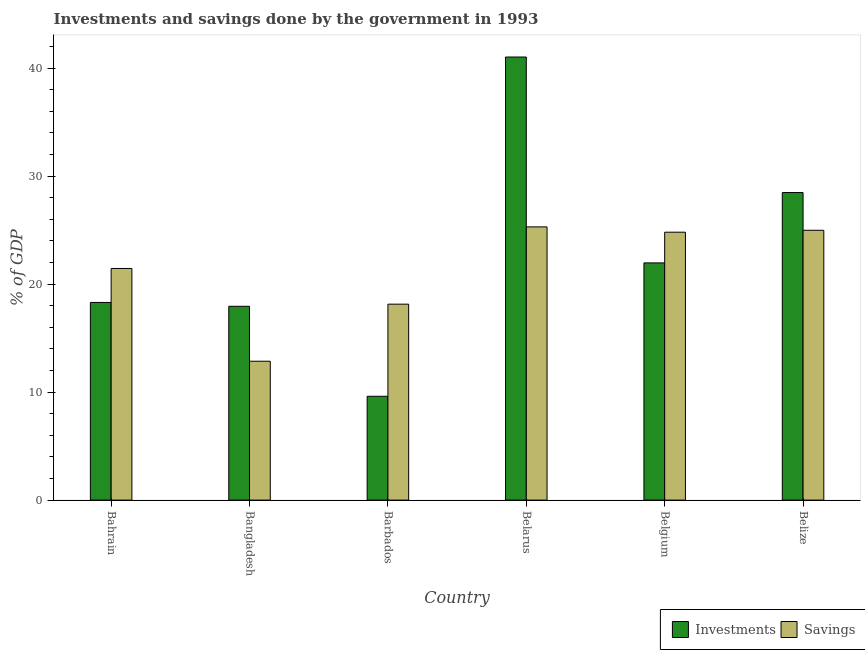How many different coloured bars are there?
Provide a short and direct response. 2. How many groups of bars are there?
Keep it short and to the point. 6. Are the number of bars per tick equal to the number of legend labels?
Offer a very short reply. Yes. How many bars are there on the 5th tick from the right?
Ensure brevity in your answer.  2. What is the label of the 4th group of bars from the left?
Give a very brief answer. Belarus. In how many cases, is the number of bars for a given country not equal to the number of legend labels?
Provide a short and direct response. 0. What is the savings of government in Belarus?
Your answer should be very brief. 25.3. Across all countries, what is the maximum savings of government?
Give a very brief answer. 25.3. Across all countries, what is the minimum savings of government?
Make the answer very short. 12.86. In which country was the investments of government maximum?
Provide a short and direct response. Belarus. In which country was the investments of government minimum?
Your answer should be very brief. Barbados. What is the total savings of government in the graph?
Provide a short and direct response. 127.55. What is the difference between the savings of government in Belarus and that in Belgium?
Provide a short and direct response. 0.49. What is the difference between the savings of government in Belize and the investments of government in Belgium?
Offer a terse response. 3.02. What is the average savings of government per country?
Your response must be concise. 21.26. What is the difference between the savings of government and investments of government in Belarus?
Your answer should be very brief. -15.73. What is the ratio of the investments of government in Bangladesh to that in Belarus?
Give a very brief answer. 0.44. Is the savings of government in Bahrain less than that in Belize?
Offer a terse response. Yes. Is the difference between the investments of government in Bahrain and Bangladesh greater than the difference between the savings of government in Bahrain and Bangladesh?
Provide a succinct answer. No. What is the difference between the highest and the second highest savings of government?
Your answer should be very brief. 0.31. What is the difference between the highest and the lowest investments of government?
Provide a short and direct response. 31.42. In how many countries, is the investments of government greater than the average investments of government taken over all countries?
Give a very brief answer. 2. Is the sum of the savings of government in Bahrain and Bangladesh greater than the maximum investments of government across all countries?
Offer a terse response. No. What does the 1st bar from the left in Bahrain represents?
Your answer should be very brief. Investments. What does the 1st bar from the right in Bahrain represents?
Your answer should be compact. Savings. How many bars are there?
Offer a very short reply. 12. How many countries are there in the graph?
Provide a short and direct response. 6. Are the values on the major ticks of Y-axis written in scientific E-notation?
Your response must be concise. No. Does the graph contain grids?
Your answer should be compact. No. How many legend labels are there?
Your answer should be very brief. 2. What is the title of the graph?
Keep it short and to the point. Investments and savings done by the government in 1993. What is the label or title of the X-axis?
Ensure brevity in your answer.  Country. What is the label or title of the Y-axis?
Give a very brief answer. % of GDP. What is the % of GDP in Investments in Bahrain?
Provide a short and direct response. 18.3. What is the % of GDP in Savings in Bahrain?
Your answer should be very brief. 21.45. What is the % of GDP in Investments in Bangladesh?
Your answer should be compact. 17.95. What is the % of GDP of Savings in Bangladesh?
Make the answer very short. 12.86. What is the % of GDP in Investments in Barbados?
Your answer should be compact. 9.61. What is the % of GDP in Savings in Barbados?
Ensure brevity in your answer.  18.14. What is the % of GDP of Investments in Belarus?
Offer a terse response. 41.03. What is the % of GDP of Savings in Belarus?
Your response must be concise. 25.3. What is the % of GDP in Investments in Belgium?
Keep it short and to the point. 21.97. What is the % of GDP in Savings in Belgium?
Your answer should be compact. 24.81. What is the % of GDP in Investments in Belize?
Ensure brevity in your answer.  28.48. What is the % of GDP of Savings in Belize?
Provide a succinct answer. 24.99. Across all countries, what is the maximum % of GDP in Investments?
Ensure brevity in your answer.  41.03. Across all countries, what is the maximum % of GDP in Savings?
Provide a succinct answer. 25.3. Across all countries, what is the minimum % of GDP of Investments?
Your answer should be compact. 9.61. Across all countries, what is the minimum % of GDP of Savings?
Give a very brief answer. 12.86. What is the total % of GDP in Investments in the graph?
Your answer should be compact. 137.34. What is the total % of GDP in Savings in the graph?
Provide a short and direct response. 127.55. What is the difference between the % of GDP in Investments in Bahrain and that in Bangladesh?
Provide a succinct answer. 0.36. What is the difference between the % of GDP of Savings in Bahrain and that in Bangladesh?
Make the answer very short. 8.59. What is the difference between the % of GDP in Investments in Bahrain and that in Barbados?
Give a very brief answer. 8.69. What is the difference between the % of GDP of Savings in Bahrain and that in Barbados?
Your answer should be compact. 3.3. What is the difference between the % of GDP of Investments in Bahrain and that in Belarus?
Keep it short and to the point. -22.73. What is the difference between the % of GDP in Savings in Bahrain and that in Belarus?
Your response must be concise. -3.85. What is the difference between the % of GDP of Investments in Bahrain and that in Belgium?
Ensure brevity in your answer.  -3.66. What is the difference between the % of GDP in Savings in Bahrain and that in Belgium?
Your response must be concise. -3.36. What is the difference between the % of GDP of Investments in Bahrain and that in Belize?
Make the answer very short. -10.18. What is the difference between the % of GDP of Savings in Bahrain and that in Belize?
Ensure brevity in your answer.  -3.54. What is the difference between the % of GDP of Investments in Bangladesh and that in Barbados?
Provide a succinct answer. 8.33. What is the difference between the % of GDP of Savings in Bangladesh and that in Barbados?
Ensure brevity in your answer.  -5.28. What is the difference between the % of GDP in Investments in Bangladesh and that in Belarus?
Provide a short and direct response. -23.08. What is the difference between the % of GDP of Savings in Bangladesh and that in Belarus?
Provide a short and direct response. -12.44. What is the difference between the % of GDP of Investments in Bangladesh and that in Belgium?
Offer a very short reply. -4.02. What is the difference between the % of GDP of Savings in Bangladesh and that in Belgium?
Offer a very short reply. -11.95. What is the difference between the % of GDP of Investments in Bangladesh and that in Belize?
Offer a terse response. -10.53. What is the difference between the % of GDP in Savings in Bangladesh and that in Belize?
Offer a terse response. -12.13. What is the difference between the % of GDP of Investments in Barbados and that in Belarus?
Provide a succinct answer. -31.42. What is the difference between the % of GDP of Savings in Barbados and that in Belarus?
Keep it short and to the point. -7.16. What is the difference between the % of GDP of Investments in Barbados and that in Belgium?
Keep it short and to the point. -12.35. What is the difference between the % of GDP in Savings in Barbados and that in Belgium?
Your answer should be compact. -6.67. What is the difference between the % of GDP in Investments in Barbados and that in Belize?
Your answer should be very brief. -18.87. What is the difference between the % of GDP of Savings in Barbados and that in Belize?
Provide a short and direct response. -6.84. What is the difference between the % of GDP of Investments in Belarus and that in Belgium?
Your answer should be compact. 19.06. What is the difference between the % of GDP of Savings in Belarus and that in Belgium?
Keep it short and to the point. 0.49. What is the difference between the % of GDP in Investments in Belarus and that in Belize?
Ensure brevity in your answer.  12.55. What is the difference between the % of GDP in Savings in Belarus and that in Belize?
Your answer should be very brief. 0.31. What is the difference between the % of GDP of Investments in Belgium and that in Belize?
Offer a terse response. -6.51. What is the difference between the % of GDP in Savings in Belgium and that in Belize?
Make the answer very short. -0.18. What is the difference between the % of GDP of Investments in Bahrain and the % of GDP of Savings in Bangladesh?
Provide a short and direct response. 5.44. What is the difference between the % of GDP of Investments in Bahrain and the % of GDP of Savings in Barbados?
Your answer should be compact. 0.16. What is the difference between the % of GDP of Investments in Bahrain and the % of GDP of Savings in Belarus?
Your answer should be very brief. -7. What is the difference between the % of GDP in Investments in Bahrain and the % of GDP in Savings in Belgium?
Ensure brevity in your answer.  -6.51. What is the difference between the % of GDP of Investments in Bahrain and the % of GDP of Savings in Belize?
Provide a succinct answer. -6.68. What is the difference between the % of GDP of Investments in Bangladesh and the % of GDP of Savings in Barbados?
Your answer should be very brief. -0.2. What is the difference between the % of GDP of Investments in Bangladesh and the % of GDP of Savings in Belarus?
Give a very brief answer. -7.35. What is the difference between the % of GDP in Investments in Bangladesh and the % of GDP in Savings in Belgium?
Your answer should be compact. -6.86. What is the difference between the % of GDP of Investments in Bangladesh and the % of GDP of Savings in Belize?
Your answer should be very brief. -7.04. What is the difference between the % of GDP of Investments in Barbados and the % of GDP of Savings in Belarus?
Provide a succinct answer. -15.69. What is the difference between the % of GDP of Investments in Barbados and the % of GDP of Savings in Belgium?
Your answer should be compact. -15.2. What is the difference between the % of GDP in Investments in Barbados and the % of GDP in Savings in Belize?
Offer a terse response. -15.37. What is the difference between the % of GDP in Investments in Belarus and the % of GDP in Savings in Belgium?
Provide a succinct answer. 16.22. What is the difference between the % of GDP of Investments in Belarus and the % of GDP of Savings in Belize?
Your response must be concise. 16.04. What is the difference between the % of GDP in Investments in Belgium and the % of GDP in Savings in Belize?
Ensure brevity in your answer.  -3.02. What is the average % of GDP in Investments per country?
Keep it short and to the point. 22.89. What is the average % of GDP of Savings per country?
Your answer should be very brief. 21.26. What is the difference between the % of GDP in Investments and % of GDP in Savings in Bahrain?
Your response must be concise. -3.15. What is the difference between the % of GDP in Investments and % of GDP in Savings in Bangladesh?
Offer a terse response. 5.09. What is the difference between the % of GDP of Investments and % of GDP of Savings in Barbados?
Ensure brevity in your answer.  -8.53. What is the difference between the % of GDP in Investments and % of GDP in Savings in Belarus?
Offer a terse response. 15.73. What is the difference between the % of GDP of Investments and % of GDP of Savings in Belgium?
Ensure brevity in your answer.  -2.84. What is the difference between the % of GDP in Investments and % of GDP in Savings in Belize?
Your answer should be compact. 3.49. What is the ratio of the % of GDP of Investments in Bahrain to that in Bangladesh?
Keep it short and to the point. 1.02. What is the ratio of the % of GDP in Savings in Bahrain to that in Bangladesh?
Make the answer very short. 1.67. What is the ratio of the % of GDP of Investments in Bahrain to that in Barbados?
Provide a short and direct response. 1.9. What is the ratio of the % of GDP of Savings in Bahrain to that in Barbados?
Provide a short and direct response. 1.18. What is the ratio of the % of GDP in Investments in Bahrain to that in Belarus?
Your response must be concise. 0.45. What is the ratio of the % of GDP in Savings in Bahrain to that in Belarus?
Your answer should be compact. 0.85. What is the ratio of the % of GDP in Savings in Bahrain to that in Belgium?
Make the answer very short. 0.86. What is the ratio of the % of GDP in Investments in Bahrain to that in Belize?
Provide a short and direct response. 0.64. What is the ratio of the % of GDP of Savings in Bahrain to that in Belize?
Give a very brief answer. 0.86. What is the ratio of the % of GDP of Investments in Bangladesh to that in Barbados?
Make the answer very short. 1.87. What is the ratio of the % of GDP of Savings in Bangladesh to that in Barbados?
Your answer should be very brief. 0.71. What is the ratio of the % of GDP of Investments in Bangladesh to that in Belarus?
Your answer should be compact. 0.44. What is the ratio of the % of GDP in Savings in Bangladesh to that in Belarus?
Offer a very short reply. 0.51. What is the ratio of the % of GDP in Investments in Bangladesh to that in Belgium?
Offer a very short reply. 0.82. What is the ratio of the % of GDP in Savings in Bangladesh to that in Belgium?
Your answer should be very brief. 0.52. What is the ratio of the % of GDP of Investments in Bangladesh to that in Belize?
Make the answer very short. 0.63. What is the ratio of the % of GDP of Savings in Bangladesh to that in Belize?
Keep it short and to the point. 0.51. What is the ratio of the % of GDP in Investments in Barbados to that in Belarus?
Keep it short and to the point. 0.23. What is the ratio of the % of GDP of Savings in Barbados to that in Belarus?
Provide a short and direct response. 0.72. What is the ratio of the % of GDP of Investments in Barbados to that in Belgium?
Ensure brevity in your answer.  0.44. What is the ratio of the % of GDP in Savings in Barbados to that in Belgium?
Provide a short and direct response. 0.73. What is the ratio of the % of GDP in Investments in Barbados to that in Belize?
Your answer should be very brief. 0.34. What is the ratio of the % of GDP of Savings in Barbados to that in Belize?
Your answer should be very brief. 0.73. What is the ratio of the % of GDP in Investments in Belarus to that in Belgium?
Your answer should be compact. 1.87. What is the ratio of the % of GDP in Savings in Belarus to that in Belgium?
Offer a very short reply. 1.02. What is the ratio of the % of GDP in Investments in Belarus to that in Belize?
Make the answer very short. 1.44. What is the ratio of the % of GDP in Savings in Belarus to that in Belize?
Give a very brief answer. 1.01. What is the ratio of the % of GDP of Investments in Belgium to that in Belize?
Your answer should be very brief. 0.77. What is the ratio of the % of GDP of Savings in Belgium to that in Belize?
Offer a very short reply. 0.99. What is the difference between the highest and the second highest % of GDP in Investments?
Make the answer very short. 12.55. What is the difference between the highest and the second highest % of GDP of Savings?
Your response must be concise. 0.31. What is the difference between the highest and the lowest % of GDP of Investments?
Offer a very short reply. 31.42. What is the difference between the highest and the lowest % of GDP in Savings?
Your answer should be compact. 12.44. 